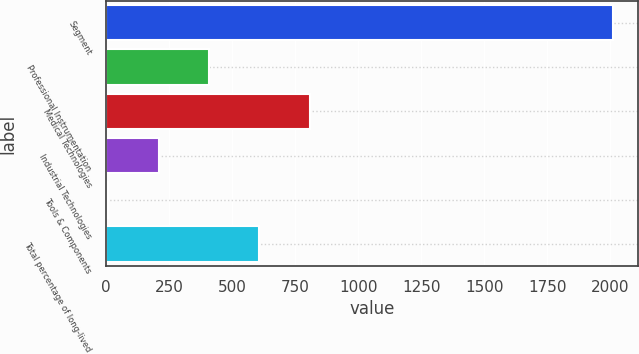Convert chart to OTSL. <chart><loc_0><loc_0><loc_500><loc_500><bar_chart><fcel>Segment<fcel>Professional Instrumentation<fcel>Medical Technologies<fcel>Industrial Technologies<fcel>Tools & Components<fcel>Total percentage of long-lived<nl><fcel>2008<fcel>408<fcel>808<fcel>208<fcel>8<fcel>608<nl></chart> 